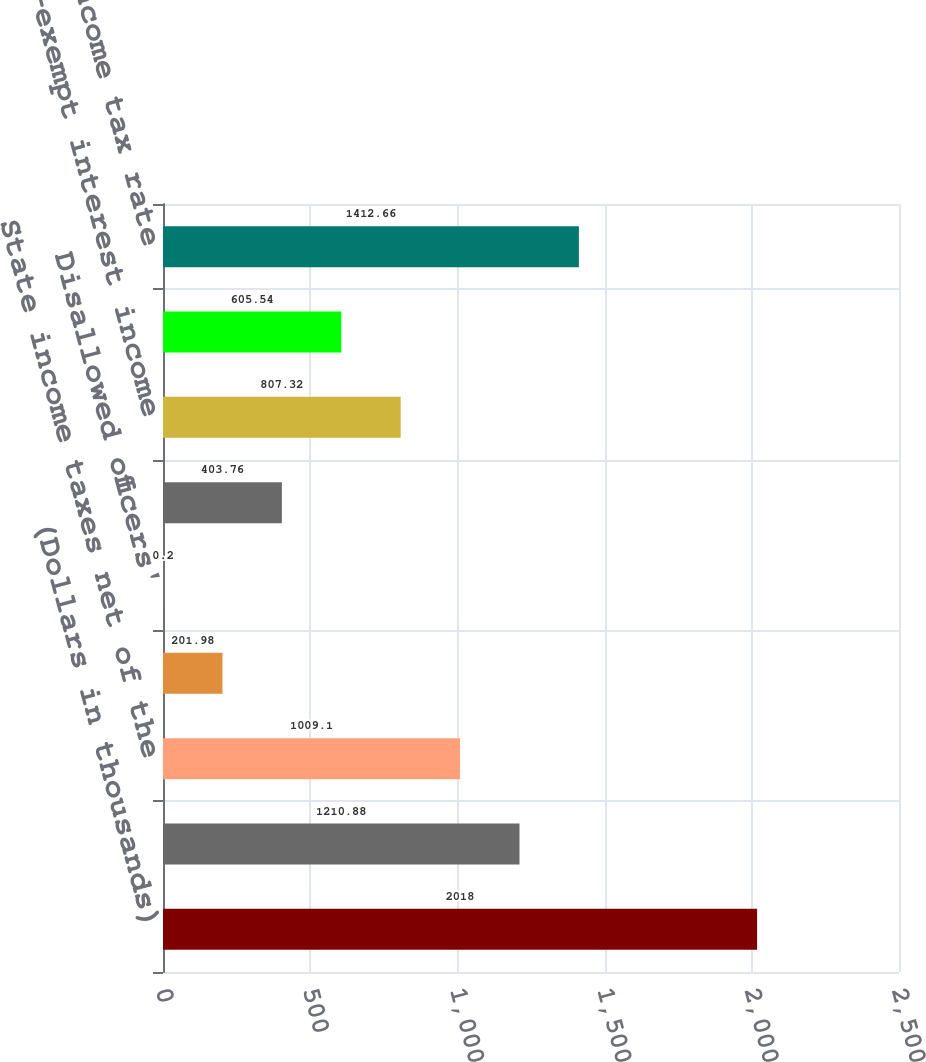Convert chart to OTSL. <chart><loc_0><loc_0><loc_500><loc_500><bar_chart><fcel>(Dollars in thousands)<fcel>Federal statutory income tax<fcel>State income taxes net of the<fcel>Meals and entertainment<fcel>Disallowed officers'<fcel>Qualified affordable housing<fcel>Tax-exempt interest income<fcel>Other net<fcel>Effective income tax rate<nl><fcel>2018<fcel>1210.88<fcel>1009.1<fcel>201.98<fcel>0.2<fcel>403.76<fcel>807.32<fcel>605.54<fcel>1412.66<nl></chart> 